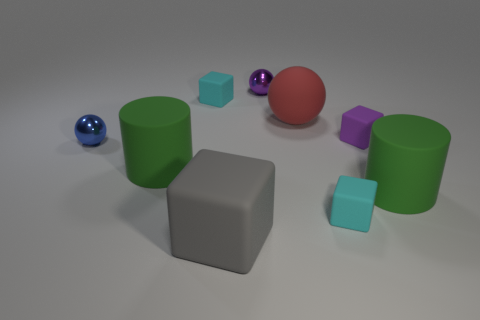There is a blue metallic thing that is left of the small cyan block in front of the large red rubber ball; what is its size?
Provide a succinct answer. Small. Are there any green cylinders made of the same material as the big ball?
Make the answer very short. Yes. There is a gray block that is the same size as the red rubber ball; what is it made of?
Your response must be concise. Rubber. There is a cylinder that is left of the purple metal ball; does it have the same color as the shiny sphere that is in front of the red rubber ball?
Offer a very short reply. No. There is a purple metal ball on the left side of the small purple rubber thing; is there a small rubber thing to the left of it?
Provide a succinct answer. Yes. There is a large green object that is to the left of the gray rubber cube; is its shape the same as the large rubber thing that is to the right of the large sphere?
Make the answer very short. Yes. Is the material of the large green object that is on the right side of the big red object the same as the cyan object in front of the large sphere?
Provide a short and direct response. Yes. There is a tiny cyan thing behind the purple matte object in front of the large sphere; what is it made of?
Give a very brief answer. Rubber. There is a cyan object behind the green object that is in front of the large green cylinder that is to the left of the big gray rubber thing; what shape is it?
Offer a terse response. Cube. What material is the large thing that is the same shape as the small purple matte thing?
Provide a short and direct response. Rubber. 